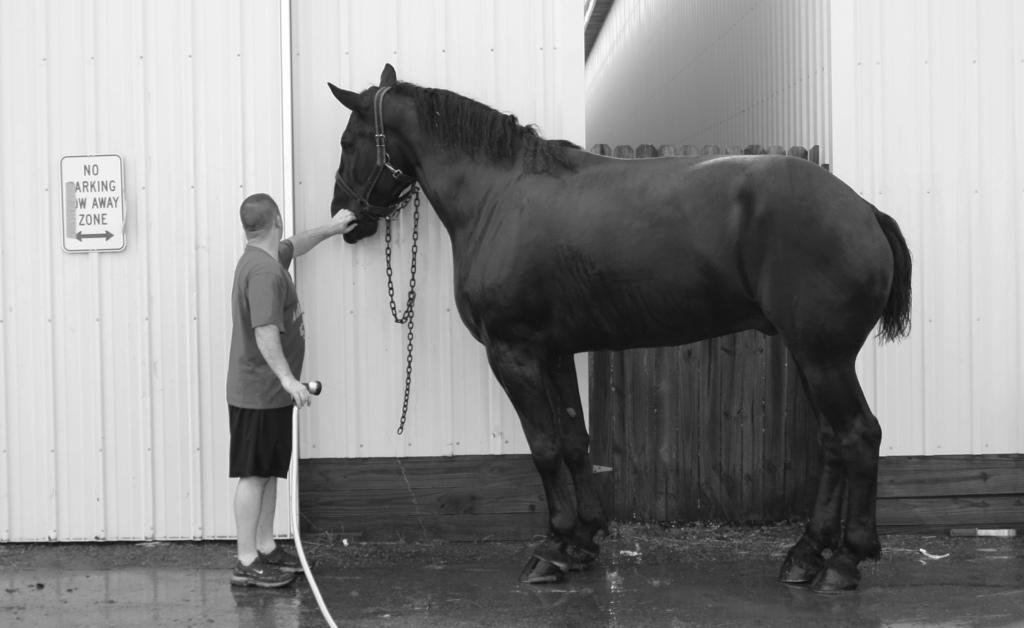What is the main subject of the image? There is a person standing in the image. What is the person doing in the image? The person is holding a horse with their hands. What can be seen in the background of the image? There is a wall in the image. What is attached to the wall? There is a board on the wall. What type of humor can be seen in the image? There is no humor present in the image; it depicts a person holding a horse. What type of journey is the person taking with the horse in the image? There is no journey depicted in the image; the person is simply holding the horse. 